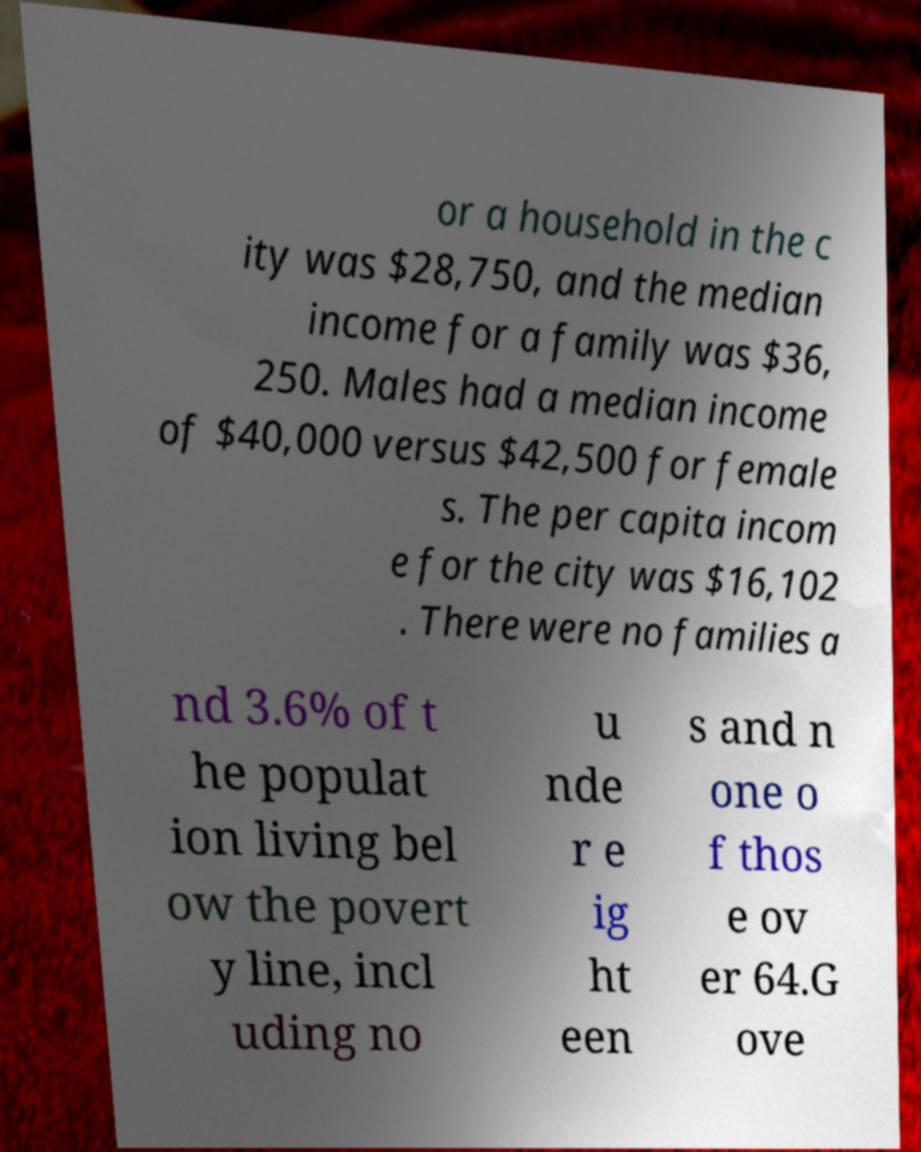What messages or text are displayed in this image? I need them in a readable, typed format. or a household in the c ity was $28,750, and the median income for a family was $36, 250. Males had a median income of $40,000 versus $42,500 for female s. The per capita incom e for the city was $16,102 . There were no families a nd 3.6% of t he populat ion living bel ow the povert y line, incl uding no u nde r e ig ht een s and n one o f thos e ov er 64.G ove 